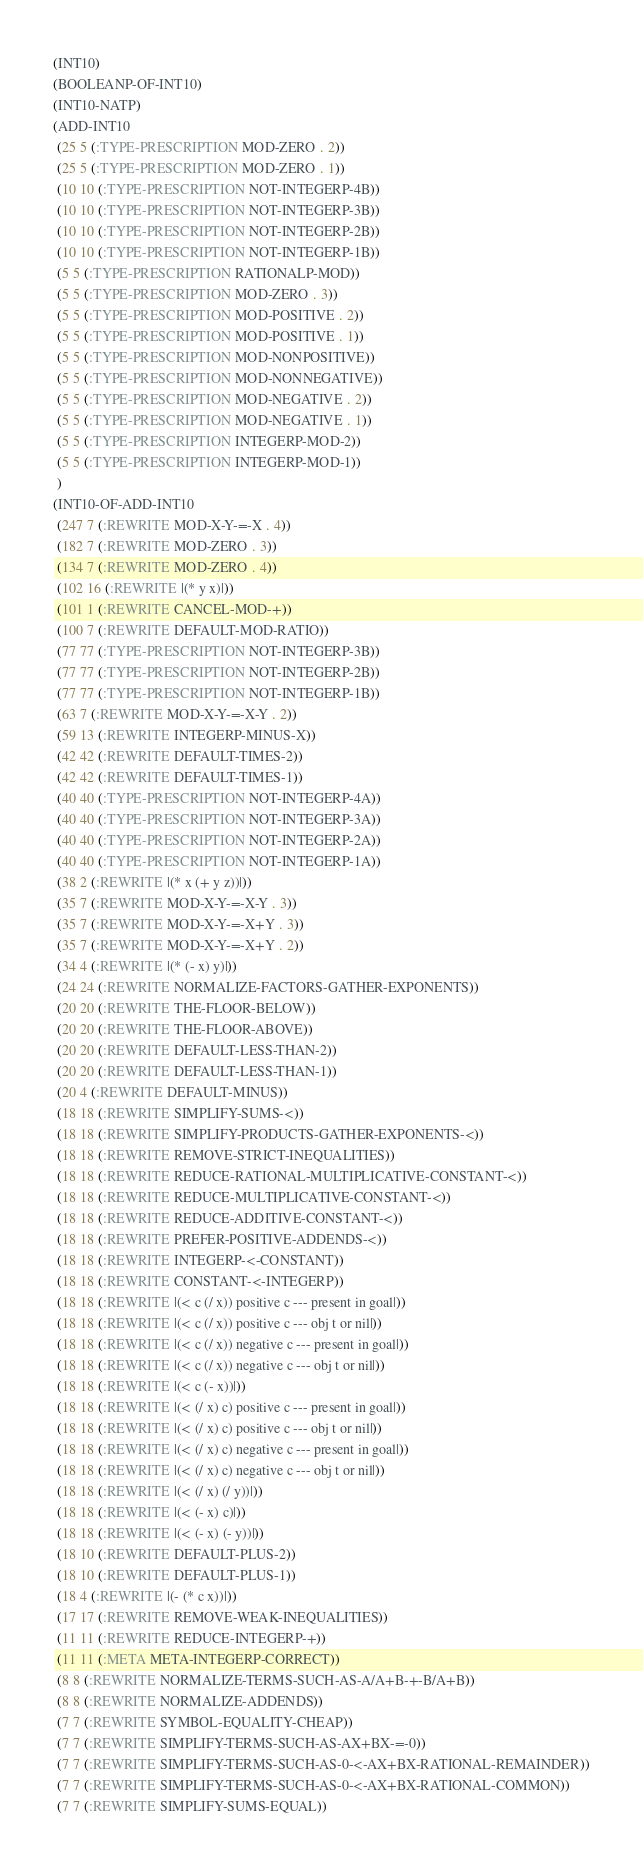<code> <loc_0><loc_0><loc_500><loc_500><_Lisp_>(INT10)
(BOOLEANP-OF-INT10)
(INT10-NATP)
(ADD-INT10
 (25 5 (:TYPE-PRESCRIPTION MOD-ZERO . 2))
 (25 5 (:TYPE-PRESCRIPTION MOD-ZERO . 1))
 (10 10 (:TYPE-PRESCRIPTION NOT-INTEGERP-4B))
 (10 10 (:TYPE-PRESCRIPTION NOT-INTEGERP-3B))
 (10 10 (:TYPE-PRESCRIPTION NOT-INTEGERP-2B))
 (10 10 (:TYPE-PRESCRIPTION NOT-INTEGERP-1B))
 (5 5 (:TYPE-PRESCRIPTION RATIONALP-MOD))
 (5 5 (:TYPE-PRESCRIPTION MOD-ZERO . 3))
 (5 5 (:TYPE-PRESCRIPTION MOD-POSITIVE . 2))
 (5 5 (:TYPE-PRESCRIPTION MOD-POSITIVE . 1))
 (5 5 (:TYPE-PRESCRIPTION MOD-NONPOSITIVE))
 (5 5 (:TYPE-PRESCRIPTION MOD-NONNEGATIVE))
 (5 5 (:TYPE-PRESCRIPTION MOD-NEGATIVE . 2))
 (5 5 (:TYPE-PRESCRIPTION MOD-NEGATIVE . 1))
 (5 5 (:TYPE-PRESCRIPTION INTEGERP-MOD-2))
 (5 5 (:TYPE-PRESCRIPTION INTEGERP-MOD-1))
 )
(INT10-OF-ADD-INT10
 (247 7 (:REWRITE MOD-X-Y-=-X . 4))
 (182 7 (:REWRITE MOD-ZERO . 3))
 (134 7 (:REWRITE MOD-ZERO . 4))
 (102 16 (:REWRITE |(* y x)|))
 (101 1 (:REWRITE CANCEL-MOD-+))
 (100 7 (:REWRITE DEFAULT-MOD-RATIO))
 (77 77 (:TYPE-PRESCRIPTION NOT-INTEGERP-3B))
 (77 77 (:TYPE-PRESCRIPTION NOT-INTEGERP-2B))
 (77 77 (:TYPE-PRESCRIPTION NOT-INTEGERP-1B))
 (63 7 (:REWRITE MOD-X-Y-=-X-Y . 2))
 (59 13 (:REWRITE INTEGERP-MINUS-X))
 (42 42 (:REWRITE DEFAULT-TIMES-2))
 (42 42 (:REWRITE DEFAULT-TIMES-1))
 (40 40 (:TYPE-PRESCRIPTION NOT-INTEGERP-4A))
 (40 40 (:TYPE-PRESCRIPTION NOT-INTEGERP-3A))
 (40 40 (:TYPE-PRESCRIPTION NOT-INTEGERP-2A))
 (40 40 (:TYPE-PRESCRIPTION NOT-INTEGERP-1A))
 (38 2 (:REWRITE |(* x (+ y z))|))
 (35 7 (:REWRITE MOD-X-Y-=-X-Y . 3))
 (35 7 (:REWRITE MOD-X-Y-=-X+Y . 3))
 (35 7 (:REWRITE MOD-X-Y-=-X+Y . 2))
 (34 4 (:REWRITE |(* (- x) y)|))
 (24 24 (:REWRITE NORMALIZE-FACTORS-GATHER-EXPONENTS))
 (20 20 (:REWRITE THE-FLOOR-BELOW))
 (20 20 (:REWRITE THE-FLOOR-ABOVE))
 (20 20 (:REWRITE DEFAULT-LESS-THAN-2))
 (20 20 (:REWRITE DEFAULT-LESS-THAN-1))
 (20 4 (:REWRITE DEFAULT-MINUS))
 (18 18 (:REWRITE SIMPLIFY-SUMS-<))
 (18 18 (:REWRITE SIMPLIFY-PRODUCTS-GATHER-EXPONENTS-<))
 (18 18 (:REWRITE REMOVE-STRICT-INEQUALITIES))
 (18 18 (:REWRITE REDUCE-RATIONAL-MULTIPLICATIVE-CONSTANT-<))
 (18 18 (:REWRITE REDUCE-MULTIPLICATIVE-CONSTANT-<))
 (18 18 (:REWRITE REDUCE-ADDITIVE-CONSTANT-<))
 (18 18 (:REWRITE PREFER-POSITIVE-ADDENDS-<))
 (18 18 (:REWRITE INTEGERP-<-CONSTANT))
 (18 18 (:REWRITE CONSTANT-<-INTEGERP))
 (18 18 (:REWRITE |(< c (/ x)) positive c --- present in goal|))
 (18 18 (:REWRITE |(< c (/ x)) positive c --- obj t or nil|))
 (18 18 (:REWRITE |(< c (/ x)) negative c --- present in goal|))
 (18 18 (:REWRITE |(< c (/ x)) negative c --- obj t or nil|))
 (18 18 (:REWRITE |(< c (- x))|))
 (18 18 (:REWRITE |(< (/ x) c) positive c --- present in goal|))
 (18 18 (:REWRITE |(< (/ x) c) positive c --- obj t or nil|))
 (18 18 (:REWRITE |(< (/ x) c) negative c --- present in goal|))
 (18 18 (:REWRITE |(< (/ x) c) negative c --- obj t or nil|))
 (18 18 (:REWRITE |(< (/ x) (/ y))|))
 (18 18 (:REWRITE |(< (- x) c)|))
 (18 18 (:REWRITE |(< (- x) (- y))|))
 (18 10 (:REWRITE DEFAULT-PLUS-2))
 (18 10 (:REWRITE DEFAULT-PLUS-1))
 (18 4 (:REWRITE |(- (* c x))|))
 (17 17 (:REWRITE REMOVE-WEAK-INEQUALITIES))
 (11 11 (:REWRITE REDUCE-INTEGERP-+))
 (11 11 (:META META-INTEGERP-CORRECT))
 (8 8 (:REWRITE NORMALIZE-TERMS-SUCH-AS-A/A+B-+-B/A+B))
 (8 8 (:REWRITE NORMALIZE-ADDENDS))
 (7 7 (:REWRITE SYMBOL-EQUALITY-CHEAP))
 (7 7 (:REWRITE SIMPLIFY-TERMS-SUCH-AS-AX+BX-=-0))
 (7 7 (:REWRITE SIMPLIFY-TERMS-SUCH-AS-0-<-AX+BX-RATIONAL-REMAINDER))
 (7 7 (:REWRITE SIMPLIFY-TERMS-SUCH-AS-0-<-AX+BX-RATIONAL-COMMON))
 (7 7 (:REWRITE SIMPLIFY-SUMS-EQUAL))</code> 